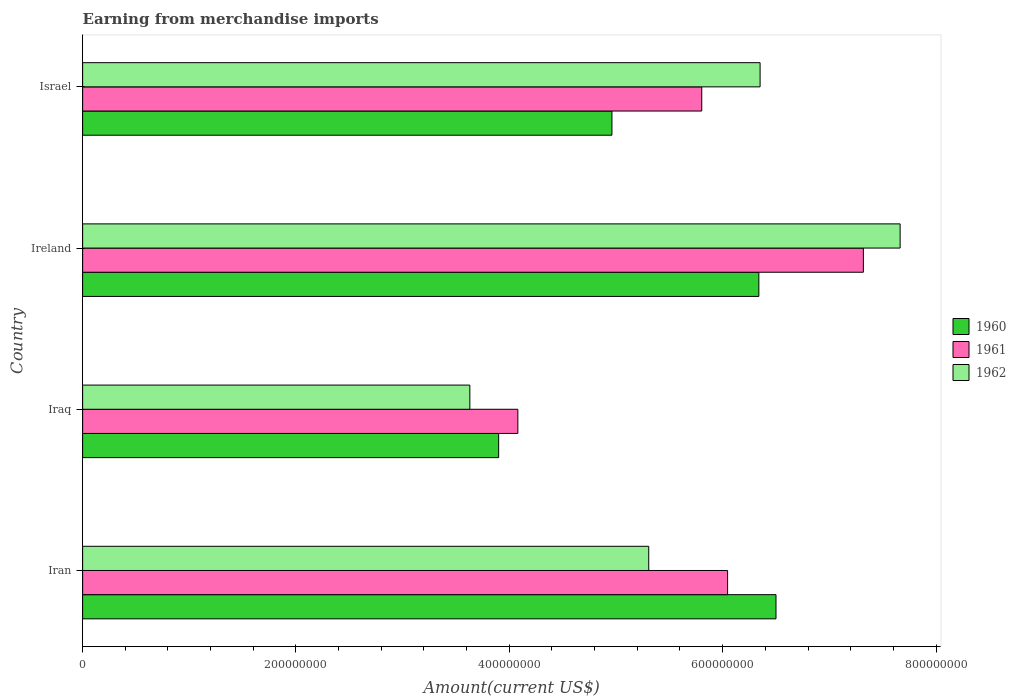How many different coloured bars are there?
Ensure brevity in your answer.  3. How many groups of bars are there?
Your response must be concise. 4. Are the number of bars on each tick of the Y-axis equal?
Your answer should be compact. Yes. How many bars are there on the 4th tick from the bottom?
Make the answer very short. 3. In how many cases, is the number of bars for a given country not equal to the number of legend labels?
Keep it short and to the point. 0. What is the amount earned from merchandise imports in 1962 in Iraq?
Your answer should be very brief. 3.63e+08. Across all countries, what is the maximum amount earned from merchandise imports in 1960?
Offer a terse response. 6.50e+08. Across all countries, what is the minimum amount earned from merchandise imports in 1960?
Ensure brevity in your answer.  3.90e+08. In which country was the amount earned from merchandise imports in 1962 maximum?
Provide a succinct answer. Ireland. In which country was the amount earned from merchandise imports in 1961 minimum?
Ensure brevity in your answer.  Iraq. What is the total amount earned from merchandise imports in 1961 in the graph?
Give a very brief answer. 2.32e+09. What is the difference between the amount earned from merchandise imports in 1961 in Iran and that in Iraq?
Offer a terse response. 1.97e+08. What is the difference between the amount earned from merchandise imports in 1960 in Ireland and the amount earned from merchandise imports in 1962 in Iran?
Keep it short and to the point. 1.03e+08. What is the average amount earned from merchandise imports in 1960 per country?
Provide a short and direct response. 5.43e+08. What is the difference between the amount earned from merchandise imports in 1961 and amount earned from merchandise imports in 1960 in Ireland?
Provide a succinct answer. 9.80e+07. In how many countries, is the amount earned from merchandise imports in 1962 greater than 400000000 US$?
Give a very brief answer. 3. What is the ratio of the amount earned from merchandise imports in 1961 in Iran to that in Iraq?
Ensure brevity in your answer.  1.48. Is the amount earned from merchandise imports in 1960 in Ireland less than that in Israel?
Offer a terse response. No. What is the difference between the highest and the second highest amount earned from merchandise imports in 1960?
Offer a very short reply. 1.61e+07. What is the difference between the highest and the lowest amount earned from merchandise imports in 1962?
Your answer should be compact. 4.03e+08. In how many countries, is the amount earned from merchandise imports in 1961 greater than the average amount earned from merchandise imports in 1961 taken over all countries?
Give a very brief answer. 2. What does the 1st bar from the top in Israel represents?
Provide a short and direct response. 1962. Is it the case that in every country, the sum of the amount earned from merchandise imports in 1960 and amount earned from merchandise imports in 1961 is greater than the amount earned from merchandise imports in 1962?
Your answer should be very brief. Yes. How many bars are there?
Give a very brief answer. 12. Are all the bars in the graph horizontal?
Your answer should be compact. Yes. How many countries are there in the graph?
Keep it short and to the point. 4. Does the graph contain any zero values?
Offer a very short reply. No. How many legend labels are there?
Give a very brief answer. 3. What is the title of the graph?
Offer a terse response. Earning from merchandise imports. What is the label or title of the X-axis?
Make the answer very short. Amount(current US$). What is the Amount(current US$) of 1960 in Iran?
Your answer should be very brief. 6.50e+08. What is the Amount(current US$) of 1961 in Iran?
Your answer should be compact. 6.05e+08. What is the Amount(current US$) of 1962 in Iran?
Provide a succinct answer. 5.31e+08. What is the Amount(current US$) in 1960 in Iraq?
Your response must be concise. 3.90e+08. What is the Amount(current US$) in 1961 in Iraq?
Provide a short and direct response. 4.08e+08. What is the Amount(current US$) of 1962 in Iraq?
Your response must be concise. 3.63e+08. What is the Amount(current US$) of 1960 in Ireland?
Your response must be concise. 6.34e+08. What is the Amount(current US$) of 1961 in Ireland?
Your answer should be very brief. 7.32e+08. What is the Amount(current US$) in 1962 in Ireland?
Give a very brief answer. 7.66e+08. What is the Amount(current US$) in 1960 in Israel?
Keep it short and to the point. 4.96e+08. What is the Amount(current US$) of 1961 in Israel?
Give a very brief answer. 5.80e+08. What is the Amount(current US$) in 1962 in Israel?
Offer a very short reply. 6.35e+08. Across all countries, what is the maximum Amount(current US$) of 1960?
Make the answer very short. 6.50e+08. Across all countries, what is the maximum Amount(current US$) of 1961?
Your answer should be compact. 7.32e+08. Across all countries, what is the maximum Amount(current US$) in 1962?
Make the answer very short. 7.66e+08. Across all countries, what is the minimum Amount(current US$) in 1960?
Make the answer very short. 3.90e+08. Across all countries, what is the minimum Amount(current US$) of 1961?
Your answer should be compact. 4.08e+08. Across all countries, what is the minimum Amount(current US$) of 1962?
Your answer should be compact. 3.63e+08. What is the total Amount(current US$) in 1960 in the graph?
Provide a short and direct response. 2.17e+09. What is the total Amount(current US$) of 1961 in the graph?
Provide a succinct answer. 2.32e+09. What is the total Amount(current US$) in 1962 in the graph?
Your answer should be compact. 2.30e+09. What is the difference between the Amount(current US$) in 1960 in Iran and that in Iraq?
Keep it short and to the point. 2.60e+08. What is the difference between the Amount(current US$) in 1961 in Iran and that in Iraq?
Make the answer very short. 1.97e+08. What is the difference between the Amount(current US$) in 1962 in Iran and that in Iraq?
Provide a short and direct response. 1.68e+08. What is the difference between the Amount(current US$) of 1960 in Iran and that in Ireland?
Keep it short and to the point. 1.61e+07. What is the difference between the Amount(current US$) in 1961 in Iran and that in Ireland?
Provide a succinct answer. -1.27e+08. What is the difference between the Amount(current US$) of 1962 in Iran and that in Ireland?
Your answer should be very brief. -2.36e+08. What is the difference between the Amount(current US$) in 1960 in Iran and that in Israel?
Provide a short and direct response. 1.54e+08. What is the difference between the Amount(current US$) of 1961 in Iran and that in Israel?
Offer a terse response. 2.42e+07. What is the difference between the Amount(current US$) of 1962 in Iran and that in Israel?
Make the answer very short. -1.04e+08. What is the difference between the Amount(current US$) in 1960 in Iraq and that in Ireland?
Keep it short and to the point. -2.44e+08. What is the difference between the Amount(current US$) of 1961 in Iraq and that in Ireland?
Your answer should be very brief. -3.24e+08. What is the difference between the Amount(current US$) in 1962 in Iraq and that in Ireland?
Keep it short and to the point. -4.03e+08. What is the difference between the Amount(current US$) of 1960 in Iraq and that in Israel?
Keep it short and to the point. -1.06e+08. What is the difference between the Amount(current US$) of 1961 in Iraq and that in Israel?
Your answer should be compact. -1.72e+08. What is the difference between the Amount(current US$) of 1962 in Iraq and that in Israel?
Make the answer very short. -2.72e+08. What is the difference between the Amount(current US$) in 1960 in Ireland and that in Israel?
Your response must be concise. 1.38e+08. What is the difference between the Amount(current US$) of 1961 in Ireland and that in Israel?
Offer a very short reply. 1.52e+08. What is the difference between the Amount(current US$) of 1962 in Ireland and that in Israel?
Provide a short and direct response. 1.31e+08. What is the difference between the Amount(current US$) of 1960 in Iran and the Amount(current US$) of 1961 in Iraq?
Your answer should be very brief. 2.42e+08. What is the difference between the Amount(current US$) of 1960 in Iran and the Amount(current US$) of 1962 in Iraq?
Your answer should be compact. 2.87e+08. What is the difference between the Amount(current US$) of 1961 in Iran and the Amount(current US$) of 1962 in Iraq?
Make the answer very short. 2.42e+08. What is the difference between the Amount(current US$) of 1960 in Iran and the Amount(current US$) of 1961 in Ireland?
Offer a very short reply. -8.19e+07. What is the difference between the Amount(current US$) of 1960 in Iran and the Amount(current US$) of 1962 in Ireland?
Make the answer very short. -1.16e+08. What is the difference between the Amount(current US$) in 1961 in Iran and the Amount(current US$) in 1962 in Ireland?
Your answer should be very brief. -1.62e+08. What is the difference between the Amount(current US$) in 1960 in Iran and the Amount(current US$) in 1961 in Israel?
Provide a short and direct response. 6.96e+07. What is the difference between the Amount(current US$) in 1960 in Iran and the Amount(current US$) in 1962 in Israel?
Offer a very short reply. 1.49e+07. What is the difference between the Amount(current US$) of 1961 in Iran and the Amount(current US$) of 1962 in Israel?
Provide a short and direct response. -3.05e+07. What is the difference between the Amount(current US$) in 1960 in Iraq and the Amount(current US$) in 1961 in Ireland?
Ensure brevity in your answer.  -3.42e+08. What is the difference between the Amount(current US$) in 1960 in Iraq and the Amount(current US$) in 1962 in Ireland?
Provide a succinct answer. -3.76e+08. What is the difference between the Amount(current US$) of 1961 in Iraq and the Amount(current US$) of 1962 in Ireland?
Your answer should be very brief. -3.58e+08. What is the difference between the Amount(current US$) in 1960 in Iraq and the Amount(current US$) in 1961 in Israel?
Give a very brief answer. -1.90e+08. What is the difference between the Amount(current US$) in 1960 in Iraq and the Amount(current US$) in 1962 in Israel?
Provide a short and direct response. -2.45e+08. What is the difference between the Amount(current US$) in 1961 in Iraq and the Amount(current US$) in 1962 in Israel?
Give a very brief answer. -2.27e+08. What is the difference between the Amount(current US$) of 1960 in Ireland and the Amount(current US$) of 1961 in Israel?
Keep it short and to the point. 5.35e+07. What is the difference between the Amount(current US$) of 1960 in Ireland and the Amount(current US$) of 1962 in Israel?
Give a very brief answer. -1.18e+06. What is the difference between the Amount(current US$) of 1961 in Ireland and the Amount(current US$) of 1962 in Israel?
Your answer should be very brief. 9.68e+07. What is the average Amount(current US$) in 1960 per country?
Your answer should be compact. 5.43e+08. What is the average Amount(current US$) in 1961 per country?
Provide a succinct answer. 5.81e+08. What is the average Amount(current US$) of 1962 per country?
Offer a terse response. 5.74e+08. What is the difference between the Amount(current US$) in 1960 and Amount(current US$) in 1961 in Iran?
Keep it short and to the point. 4.54e+07. What is the difference between the Amount(current US$) in 1960 and Amount(current US$) in 1962 in Iran?
Provide a succinct answer. 1.19e+08. What is the difference between the Amount(current US$) in 1961 and Amount(current US$) in 1962 in Iran?
Provide a succinct answer. 7.39e+07. What is the difference between the Amount(current US$) of 1960 and Amount(current US$) of 1961 in Iraq?
Your response must be concise. -1.80e+07. What is the difference between the Amount(current US$) of 1960 and Amount(current US$) of 1962 in Iraq?
Provide a succinct answer. 2.70e+07. What is the difference between the Amount(current US$) in 1961 and Amount(current US$) in 1962 in Iraq?
Your answer should be compact. 4.50e+07. What is the difference between the Amount(current US$) in 1960 and Amount(current US$) in 1961 in Ireland?
Your answer should be compact. -9.80e+07. What is the difference between the Amount(current US$) of 1960 and Amount(current US$) of 1962 in Ireland?
Keep it short and to the point. -1.32e+08. What is the difference between the Amount(current US$) of 1961 and Amount(current US$) of 1962 in Ireland?
Give a very brief answer. -3.44e+07. What is the difference between the Amount(current US$) of 1960 and Amount(current US$) of 1961 in Israel?
Your answer should be very brief. -8.42e+07. What is the difference between the Amount(current US$) of 1960 and Amount(current US$) of 1962 in Israel?
Your response must be concise. -1.39e+08. What is the difference between the Amount(current US$) in 1961 and Amount(current US$) in 1962 in Israel?
Make the answer very short. -5.47e+07. What is the ratio of the Amount(current US$) in 1960 in Iran to that in Iraq?
Provide a short and direct response. 1.67. What is the ratio of the Amount(current US$) of 1961 in Iran to that in Iraq?
Provide a short and direct response. 1.48. What is the ratio of the Amount(current US$) of 1962 in Iran to that in Iraq?
Your answer should be very brief. 1.46. What is the ratio of the Amount(current US$) of 1960 in Iran to that in Ireland?
Keep it short and to the point. 1.03. What is the ratio of the Amount(current US$) of 1961 in Iran to that in Ireland?
Offer a terse response. 0.83. What is the ratio of the Amount(current US$) of 1962 in Iran to that in Ireland?
Give a very brief answer. 0.69. What is the ratio of the Amount(current US$) in 1960 in Iran to that in Israel?
Your response must be concise. 1.31. What is the ratio of the Amount(current US$) in 1961 in Iran to that in Israel?
Provide a short and direct response. 1.04. What is the ratio of the Amount(current US$) of 1962 in Iran to that in Israel?
Offer a very short reply. 0.84. What is the ratio of the Amount(current US$) in 1960 in Iraq to that in Ireland?
Give a very brief answer. 0.62. What is the ratio of the Amount(current US$) in 1961 in Iraq to that in Ireland?
Ensure brevity in your answer.  0.56. What is the ratio of the Amount(current US$) of 1962 in Iraq to that in Ireland?
Make the answer very short. 0.47. What is the ratio of the Amount(current US$) of 1960 in Iraq to that in Israel?
Your response must be concise. 0.79. What is the ratio of the Amount(current US$) in 1961 in Iraq to that in Israel?
Ensure brevity in your answer.  0.7. What is the ratio of the Amount(current US$) of 1962 in Iraq to that in Israel?
Give a very brief answer. 0.57. What is the ratio of the Amount(current US$) of 1960 in Ireland to that in Israel?
Ensure brevity in your answer.  1.28. What is the ratio of the Amount(current US$) in 1961 in Ireland to that in Israel?
Give a very brief answer. 1.26. What is the ratio of the Amount(current US$) in 1962 in Ireland to that in Israel?
Keep it short and to the point. 1.21. What is the difference between the highest and the second highest Amount(current US$) in 1960?
Give a very brief answer. 1.61e+07. What is the difference between the highest and the second highest Amount(current US$) in 1961?
Your answer should be very brief. 1.27e+08. What is the difference between the highest and the second highest Amount(current US$) in 1962?
Provide a succinct answer. 1.31e+08. What is the difference between the highest and the lowest Amount(current US$) in 1960?
Ensure brevity in your answer.  2.60e+08. What is the difference between the highest and the lowest Amount(current US$) of 1961?
Provide a succinct answer. 3.24e+08. What is the difference between the highest and the lowest Amount(current US$) of 1962?
Ensure brevity in your answer.  4.03e+08. 